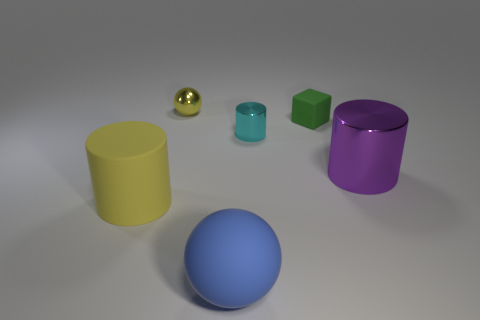Subtract all yellow cylinders. How many cylinders are left? 2 Add 2 green blocks. How many objects exist? 8 Subtract 1 cylinders. How many cylinders are left? 2 Subtract all yellow cylinders. How many cylinders are left? 2 Subtract all spheres. How many objects are left? 4 Add 3 tiny green cubes. How many tiny green cubes exist? 4 Subtract 0 green balls. How many objects are left? 6 Subtract all purple cylinders. Subtract all brown spheres. How many cylinders are left? 2 Subtract all tiny yellow shiny cylinders. Subtract all small matte things. How many objects are left? 5 Add 1 small cylinders. How many small cylinders are left? 2 